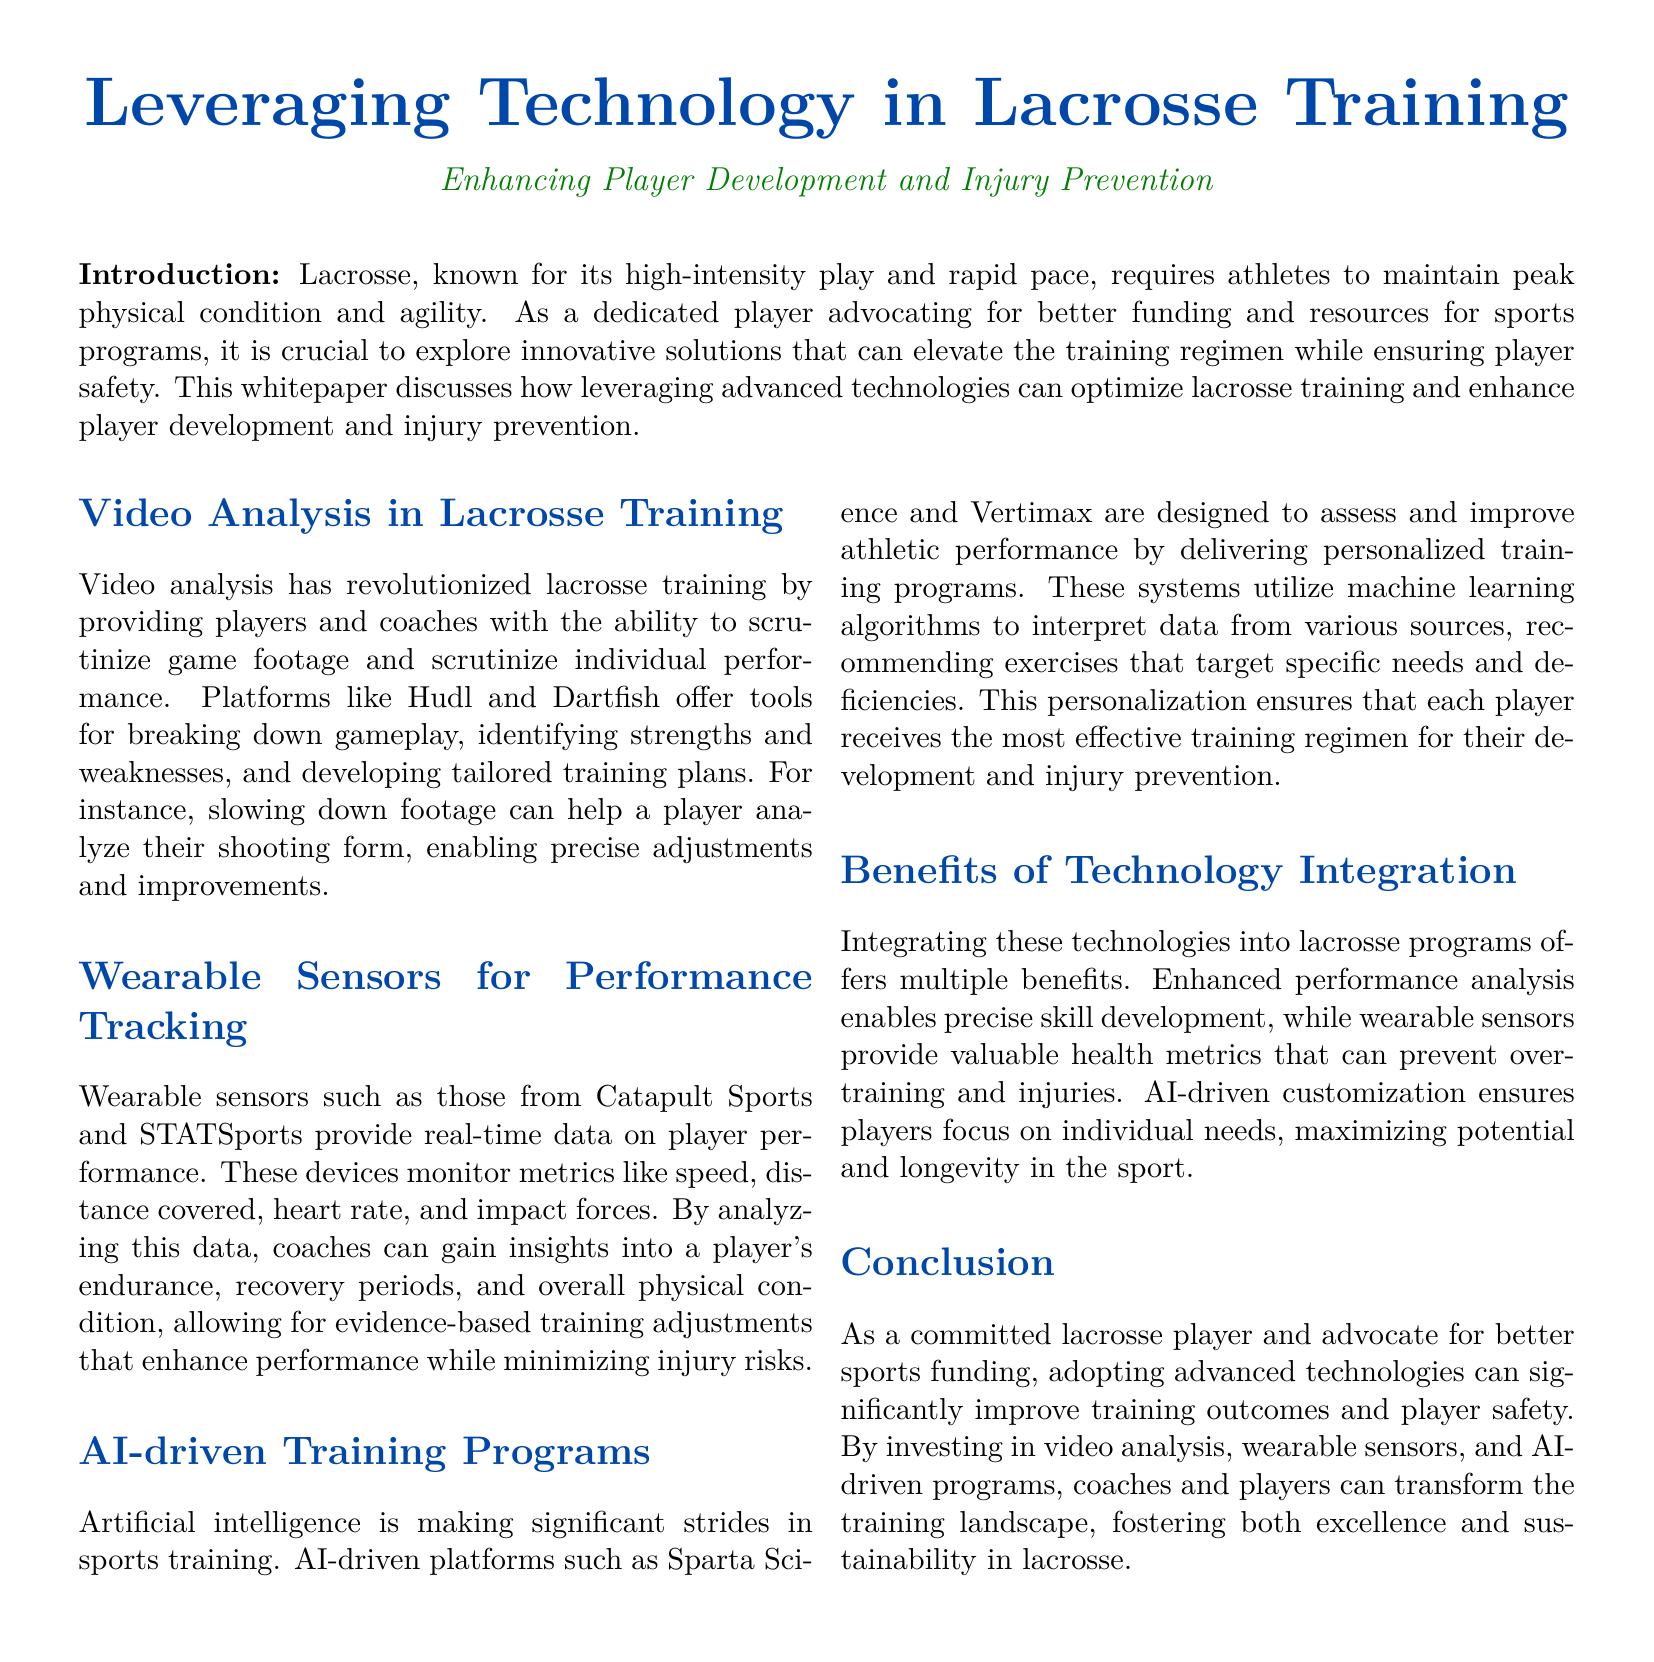What is the main focus of the whitepaper? The main focus is on leveraging advanced technologies in lacrosse training to enhance player development and prevent injuries.
Answer: enhancing player development and injury prevention Which technology is used for analyzing game footage? Video analysis tools like Hudl and Dartfish are mentioned for this purpose.
Answer: Hudl and Dartfish What type of data do wearable sensors monitor? Wearable sensors monitor metrics like speed, distance covered, heart rate, and impact forces.
Answer: speed, distance covered, heart rate, and impact forces Which AI-driven platform is designed to improve athletic performance? Sparta Science and Vertimax are mentioned platforms that assess and improve performance.
Answer: Sparta Science and Vertimax What is one benefit of integrating technology into lacrosse programs? Enhanced performance analysis enables precise skill development, among other benefits.
Answer: precise skill development Why is it important to adopt advanced technologies in lacrosse? Adopting advanced technologies significantly improves training outcomes and player safety.
Answer: improves training outcomes and player safety What is the purpose of AI-driven training programs? They deliver personalized training programs based on machine learning algorithms.
Answer: personalized training programs How does video analysis help players? By allowing players to analyze their shooting form for precise adjustments.
Answer: analyze shooting form for precise adjustments 